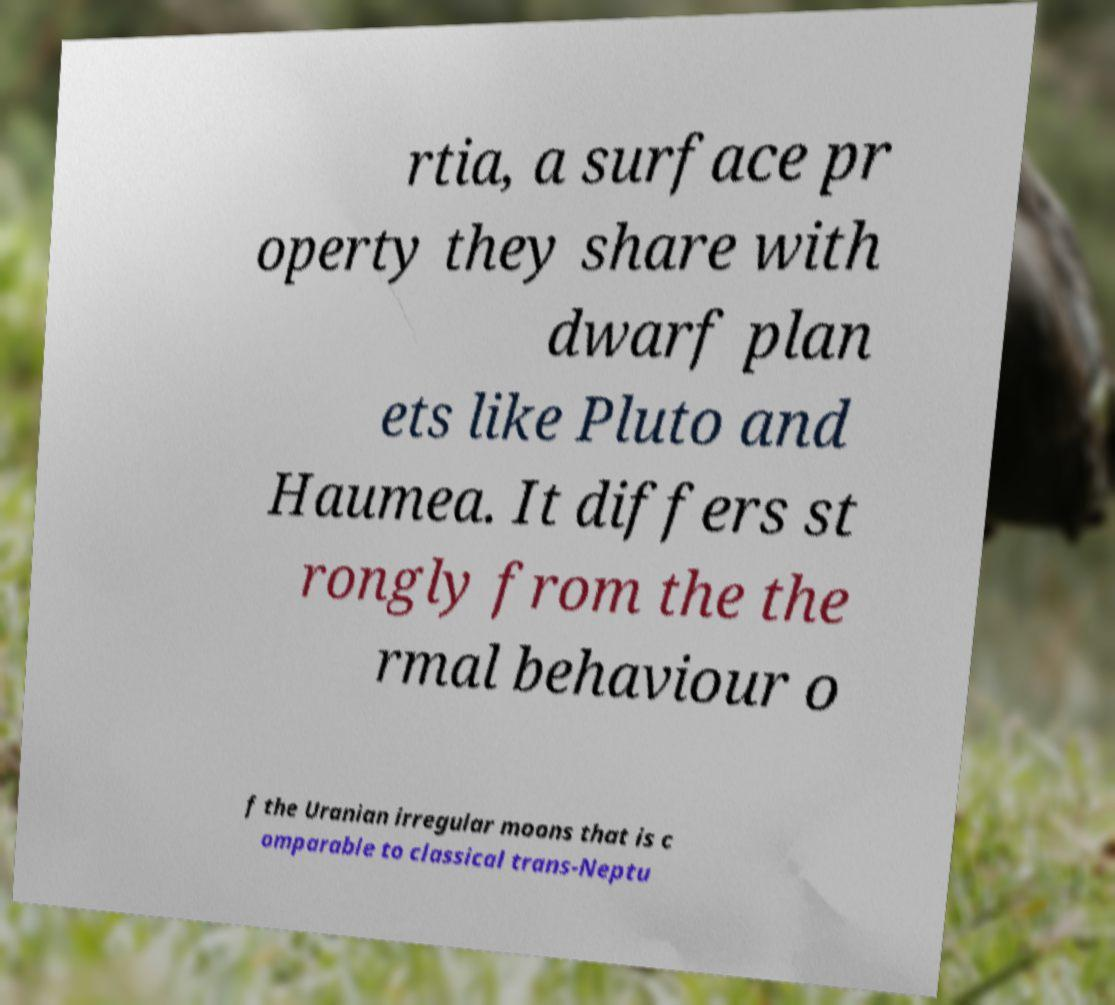For documentation purposes, I need the text within this image transcribed. Could you provide that? rtia, a surface pr operty they share with dwarf plan ets like Pluto and Haumea. It differs st rongly from the the rmal behaviour o f the Uranian irregular moons that is c omparable to classical trans-Neptu 